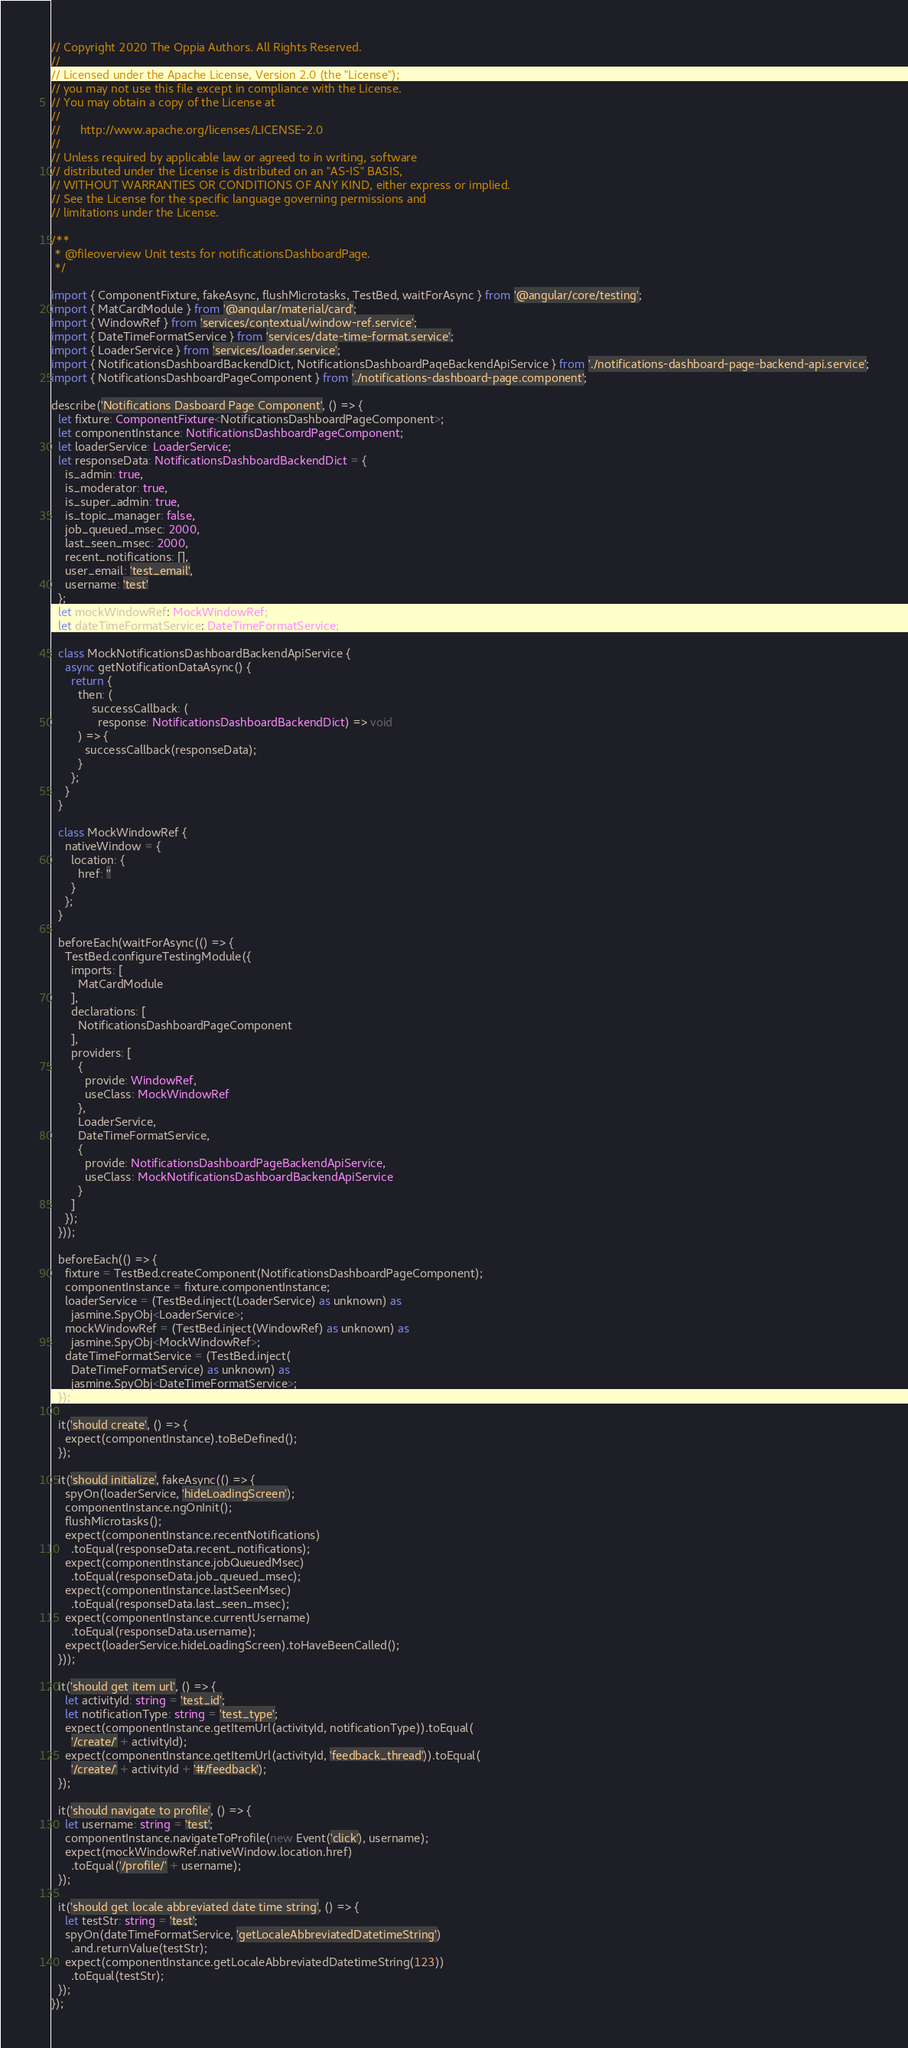<code> <loc_0><loc_0><loc_500><loc_500><_TypeScript_>// Copyright 2020 The Oppia Authors. All Rights Reserved.
//
// Licensed under the Apache License, Version 2.0 (the "License");
// you may not use this file except in compliance with the License.
// You may obtain a copy of the License at
//
//      http://www.apache.org/licenses/LICENSE-2.0
//
// Unless required by applicable law or agreed to in writing, software
// distributed under the License is distributed on an "AS-IS" BASIS,
// WITHOUT WARRANTIES OR CONDITIONS OF ANY KIND, either express or implied.
// See the License for the specific language governing permissions and
// limitations under the License.

/**
 * @fileoverview Unit tests for notificationsDashboardPage.
 */

import { ComponentFixture, fakeAsync, flushMicrotasks, TestBed, waitForAsync } from '@angular/core/testing';
import { MatCardModule } from '@angular/material/card';
import { WindowRef } from 'services/contextual/window-ref.service';
import { DateTimeFormatService } from 'services/date-time-format.service';
import { LoaderService } from 'services/loader.service';
import { NotificationsDashboardBackendDict, NotificationsDashboardPageBackendApiService } from './notifications-dashboard-page-backend-api.service';
import { NotificationsDashboardPageComponent } from './notifications-dashboard-page.component';

describe('Notifications Dasboard Page Component', () => {
  let fixture: ComponentFixture<NotificationsDashboardPageComponent>;
  let componentInstance: NotificationsDashboardPageComponent;
  let loaderService: LoaderService;
  let responseData: NotificationsDashboardBackendDict = {
    is_admin: true,
    is_moderator: true,
    is_super_admin: true,
    is_topic_manager: false,
    job_queued_msec: 2000,
    last_seen_msec: 2000,
    recent_notifications: [],
    user_email: 'test_email',
    username: 'test'
  };
  let mockWindowRef: MockWindowRef;
  let dateTimeFormatService: DateTimeFormatService;

  class MockNotificationsDashboardBackendApiService {
    async getNotificationDataAsync() {
      return {
        then: (
            successCallback: (
              response: NotificationsDashboardBackendDict) => void
        ) => {
          successCallback(responseData);
        }
      };
    }
  }

  class MockWindowRef {
    nativeWindow = {
      location: {
        href: ''
      }
    };
  }

  beforeEach(waitForAsync(() => {
    TestBed.configureTestingModule({
      imports: [
        MatCardModule
      ],
      declarations: [
        NotificationsDashboardPageComponent
      ],
      providers: [
        {
          provide: WindowRef,
          useClass: MockWindowRef
        },
        LoaderService,
        DateTimeFormatService,
        {
          provide: NotificationsDashboardPageBackendApiService,
          useClass: MockNotificationsDashboardBackendApiService
        }
      ]
    });
  }));

  beforeEach(() => {
    fixture = TestBed.createComponent(NotificationsDashboardPageComponent);
    componentInstance = fixture.componentInstance;
    loaderService = (TestBed.inject(LoaderService) as unknown) as
      jasmine.SpyObj<LoaderService>;
    mockWindowRef = (TestBed.inject(WindowRef) as unknown) as
      jasmine.SpyObj<MockWindowRef>;
    dateTimeFormatService = (TestBed.inject(
      DateTimeFormatService) as unknown) as
      jasmine.SpyObj<DateTimeFormatService>;
  });

  it('should create', () => {
    expect(componentInstance).toBeDefined();
  });

  it('should initialize', fakeAsync(() => {
    spyOn(loaderService, 'hideLoadingScreen');
    componentInstance.ngOnInit();
    flushMicrotasks();
    expect(componentInstance.recentNotifications)
      .toEqual(responseData.recent_notifications);
    expect(componentInstance.jobQueuedMsec)
      .toEqual(responseData.job_queued_msec);
    expect(componentInstance.lastSeenMsec)
      .toEqual(responseData.last_seen_msec);
    expect(componentInstance.currentUsername)
      .toEqual(responseData.username);
    expect(loaderService.hideLoadingScreen).toHaveBeenCalled();
  }));

  it('should get item url', () => {
    let activityId: string = 'test_id';
    let notificationType: string = 'test_type';
    expect(componentInstance.getItemUrl(activityId, notificationType)).toEqual(
      '/create/' + activityId);
    expect(componentInstance.getItemUrl(activityId, 'feedback_thread')).toEqual(
      '/create/' + activityId + '#/feedback');
  });

  it('should navigate to profile', () => {
    let username: string = 'test';
    componentInstance.navigateToProfile(new Event('click'), username);
    expect(mockWindowRef.nativeWindow.location.href)
      .toEqual('/profile/' + username);
  });

  it('should get locale abbreviated date time string', () => {
    let testStr: string = 'test';
    spyOn(dateTimeFormatService, 'getLocaleAbbreviatedDatetimeString')
      .and.returnValue(testStr);
    expect(componentInstance.getLocaleAbbreviatedDatetimeString(123))
      .toEqual(testStr);
  });
});
</code> 